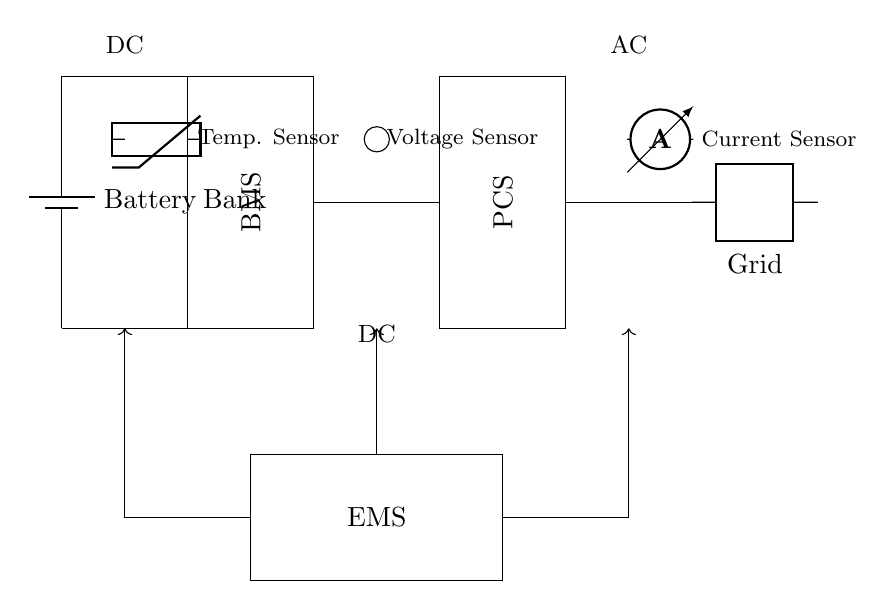What is the main purpose of the Battery Management System? The Battery Management System is essential for monitoring and managing battery performance, ensuring safe operation, and optimizing energy storage.
Answer: Monitoring and managing battery performance What type of sensors are present in the circuit? The circuit contains three types of sensors: a thermistor for temperature, a voltage sensor, and an ammeter for current.
Answer: Thermistor, voltage sensor, ammeter What does EMS stand for in this diagram? EMS stands for Energy Management System, which coordinates the operation of the entire energy storage system, including charging and discharging processes.
Answer: Energy Management System What is the voltage type at the grid connection? The voltage type at the grid connection is alternating current, as indicated by the AC label near the grid component.
Answer: AC How many main components are there in the energy storage system? There are four main components in the energy storage system: Battery Bank, Battery Management System, Power Conversion System, and Energy Management System.
Answer: Four Which component is responsible for power conversion? The Power Conversion System is responsible for the conversion of power between stored energy in batteries and the grid.
Answer: Power Conversion System What do the arrows signify in this circuit diagram? The arrows in the circuit diagram signify the direction of control signals or energy flow, indicating how information and power are transmitted between components.
Answer: Direction of control signals or energy flow 